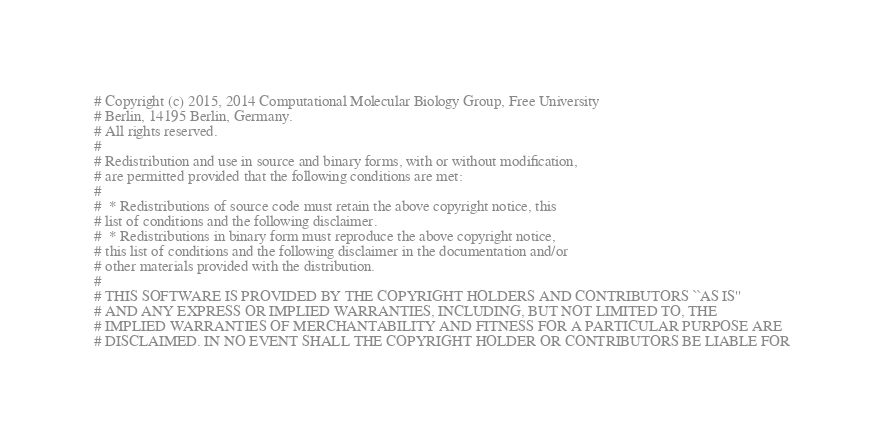Convert code to text. <code><loc_0><loc_0><loc_500><loc_500><_Python_>
# Copyright (c) 2015, 2014 Computational Molecular Biology Group, Free University
# Berlin, 14195 Berlin, Germany.
# All rights reserved.
#
# Redistribution and use in source and binary forms, with or without modification,
# are permitted provided that the following conditions are met:
#
#  * Redistributions of source code must retain the above copyright notice, this
# list of conditions and the following disclaimer.
#  * Redistributions in binary form must reproduce the above copyright notice,
# this list of conditions and the following disclaimer in the documentation and/or
# other materials provided with the distribution.
#
# THIS SOFTWARE IS PROVIDED BY THE COPYRIGHT HOLDERS AND CONTRIBUTORS ``AS IS''
# AND ANY EXPRESS OR IMPLIED WARRANTIES, INCLUDING, BUT NOT LIMITED TO, THE
# IMPLIED WARRANTIES OF MERCHANTABILITY AND FITNESS FOR A PARTICULAR PURPOSE ARE
# DISCLAIMED. IN NO EVENT SHALL THE COPYRIGHT HOLDER OR CONTRIBUTORS BE LIABLE FOR</code> 